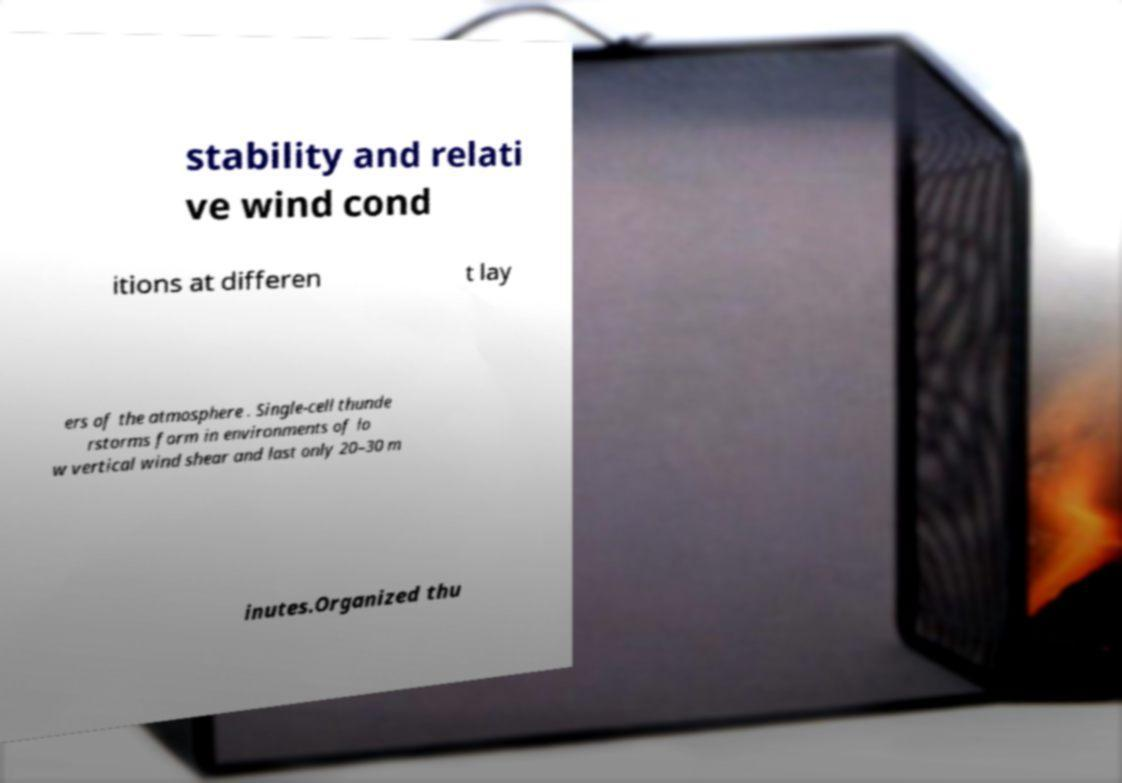What messages or text are displayed in this image? I need them in a readable, typed format. stability and relati ve wind cond itions at differen t lay ers of the atmosphere . Single-cell thunde rstorms form in environments of lo w vertical wind shear and last only 20–30 m inutes.Organized thu 